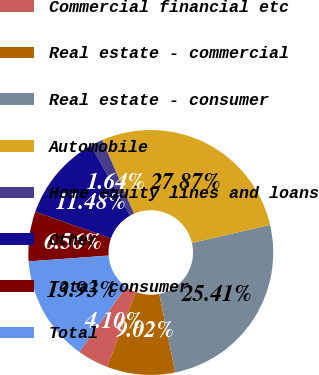Convert chart. <chart><loc_0><loc_0><loc_500><loc_500><pie_chart><fcel>Commercial financial etc<fcel>Real estate - commercial<fcel>Real estate - consumer<fcel>Automobile<fcel>Home equity lines and loans<fcel>Other<fcel>Total consumer<fcel>Total<nl><fcel>4.1%<fcel>9.02%<fcel>25.41%<fcel>27.87%<fcel>1.64%<fcel>11.48%<fcel>6.56%<fcel>13.93%<nl></chart> 